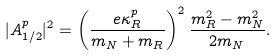<formula> <loc_0><loc_0><loc_500><loc_500>| A _ { 1 / 2 } ^ { p } | ^ { 2 } = \left ( \frac { e \kappa _ { R } ^ { p } } { m _ { N } + m _ { R } } \right ) ^ { 2 } \frac { m _ { R } ^ { 2 } - m _ { N } ^ { 2 } } { 2 m _ { N } } .</formula> 